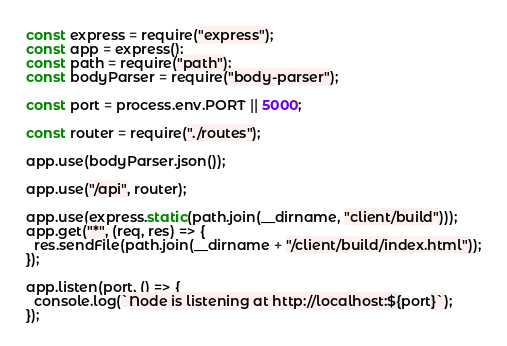Convert code to text. <code><loc_0><loc_0><loc_500><loc_500><_JavaScript_>const express = require("express");
const app = express();
const path = require("path");
const bodyParser = require("body-parser");

const port = process.env.PORT || 5000;

const router = require("./routes");

app.use(bodyParser.json());

app.use("/api", router);

app.use(express.static(path.join(__dirname, "client/build")));
app.get("*", (req, res) => {
  res.sendFile(path.join(__dirname + "/client/build/index.html"));
});

app.listen(port, () => {
  console.log(`Node is listening at http://localhost:${port}`);
});
</code> 